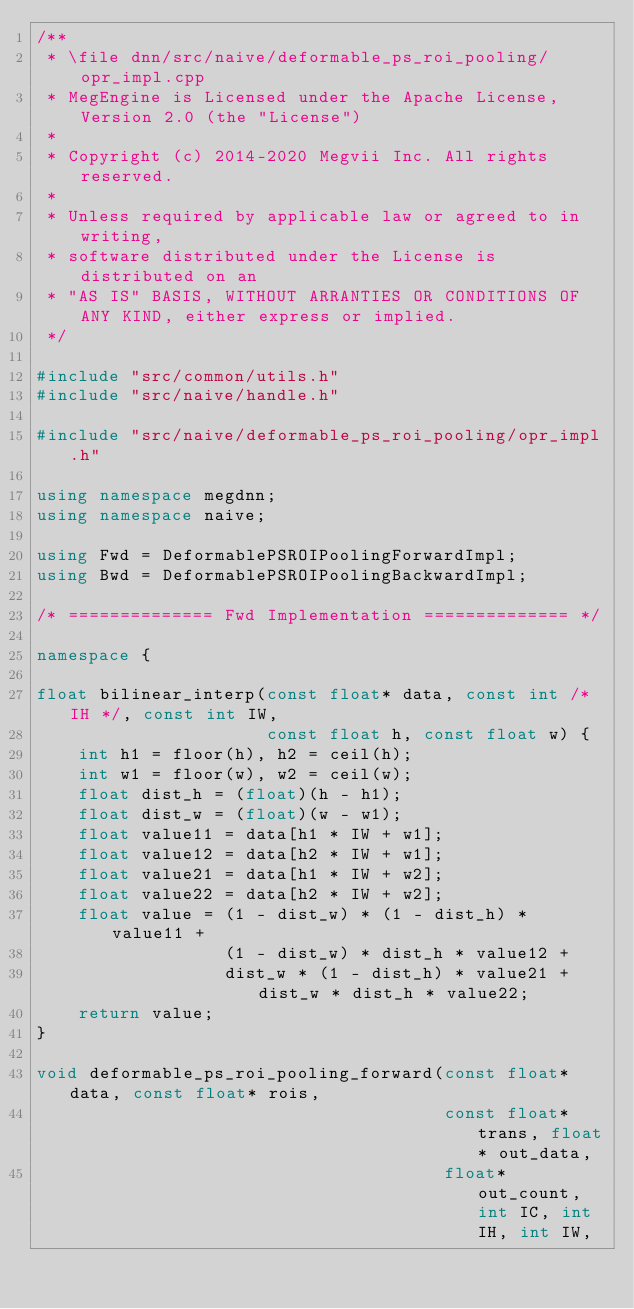Convert code to text. <code><loc_0><loc_0><loc_500><loc_500><_C++_>/**
 * \file dnn/src/naive/deformable_ps_roi_pooling/opr_impl.cpp
 * MegEngine is Licensed under the Apache License, Version 2.0 (the "License")
 *
 * Copyright (c) 2014-2020 Megvii Inc. All rights reserved.
 *
 * Unless required by applicable law or agreed to in writing,
 * software distributed under the License is distributed on an
 * "AS IS" BASIS, WITHOUT ARRANTIES OR CONDITIONS OF ANY KIND, either express or implied.
 */

#include "src/common/utils.h"
#include "src/naive/handle.h"

#include "src/naive/deformable_ps_roi_pooling/opr_impl.h"

using namespace megdnn;
using namespace naive;

using Fwd = DeformablePSROIPoolingForwardImpl;
using Bwd = DeformablePSROIPoolingBackwardImpl;

/* ============== Fwd Implementation ============== */

namespace {

float bilinear_interp(const float* data, const int /* IH */, const int IW,
                      const float h, const float w) {
    int h1 = floor(h), h2 = ceil(h);
    int w1 = floor(w), w2 = ceil(w);
    float dist_h = (float)(h - h1);
    float dist_w = (float)(w - w1);
    float value11 = data[h1 * IW + w1];
    float value12 = data[h2 * IW + w1];
    float value21 = data[h1 * IW + w2];
    float value22 = data[h2 * IW + w2];
    float value = (1 - dist_w) * (1 - dist_h) * value11 +
                  (1 - dist_w) * dist_h * value12 +
                  dist_w * (1 - dist_h) * value21 + dist_w * dist_h * value22;
    return value;
}

void deformable_ps_roi_pooling_forward(const float* data, const float* rois,
                                       const float* trans, float* out_data,
                                       float* out_count, int IC, int IH, int IW,</code> 